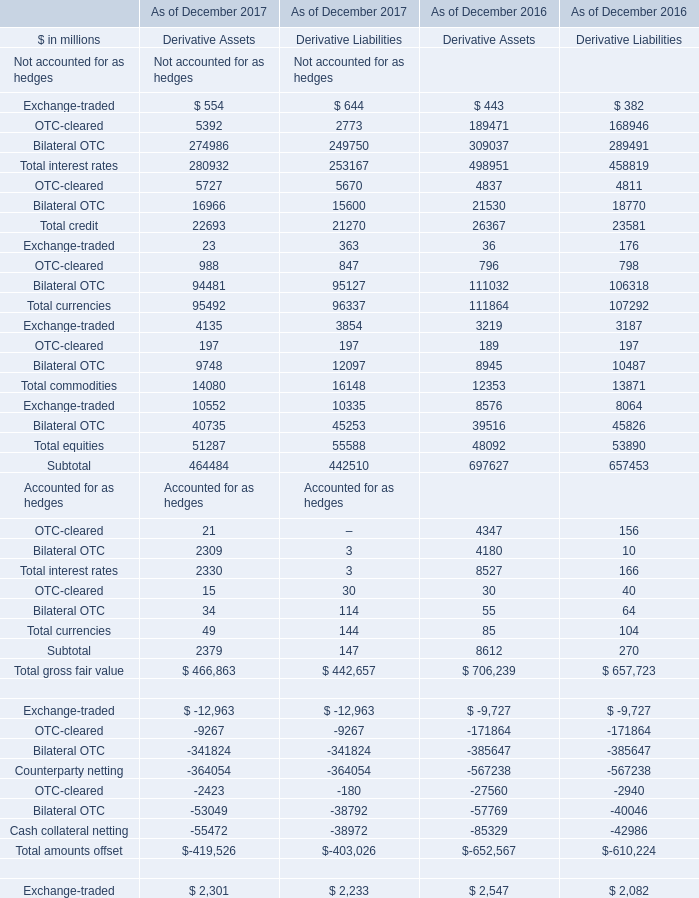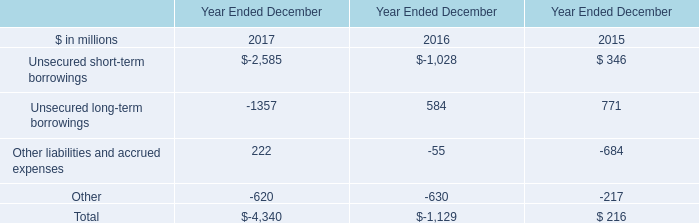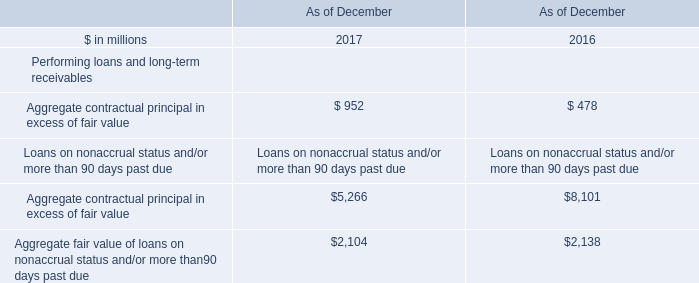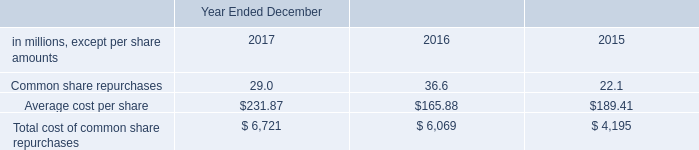what is the total amount of stock options cancelled in millions during 2017 , 2016 and 2015? 
Computations: ((4.6 + 5.5) + 2)
Answer: 12.1. 